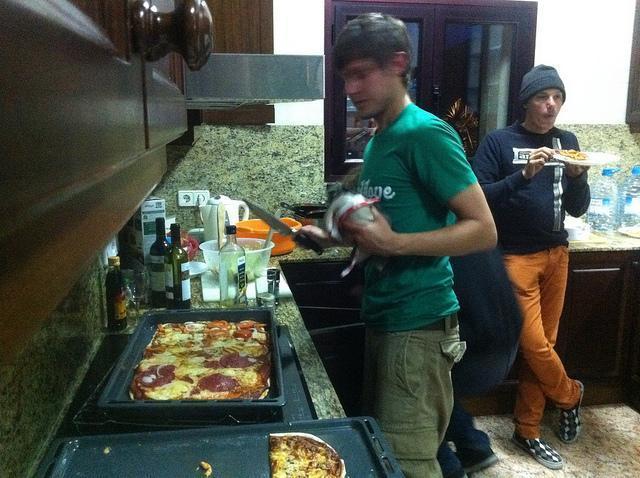How many pizzas are in the picture?
Give a very brief answer. 2. How many people are there?
Give a very brief answer. 2. 